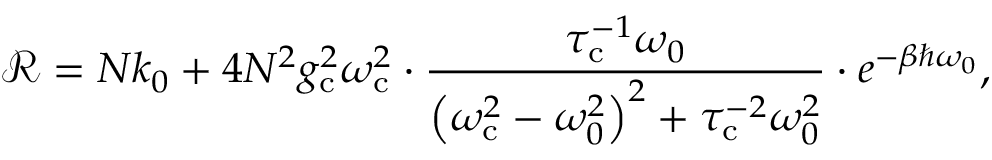Convert formula to latex. <formula><loc_0><loc_0><loc_500><loc_500>\mathcal { R } = N k _ { 0 } + { 4 N ^ { 2 } g _ { c } ^ { 2 } \omega _ { c } ^ { 2 } } \cdot \frac { \tau _ { c } ^ { - 1 } \omega _ { 0 } } { \left ( \omega _ { c } ^ { 2 } - \omega _ { 0 } ^ { 2 } \right ) ^ { 2 } + \tau _ { c } ^ { - 2 } \omega _ { 0 } ^ { 2 } } \cdot e ^ { - \beta \hbar { \omega } _ { 0 } } ,</formula> 